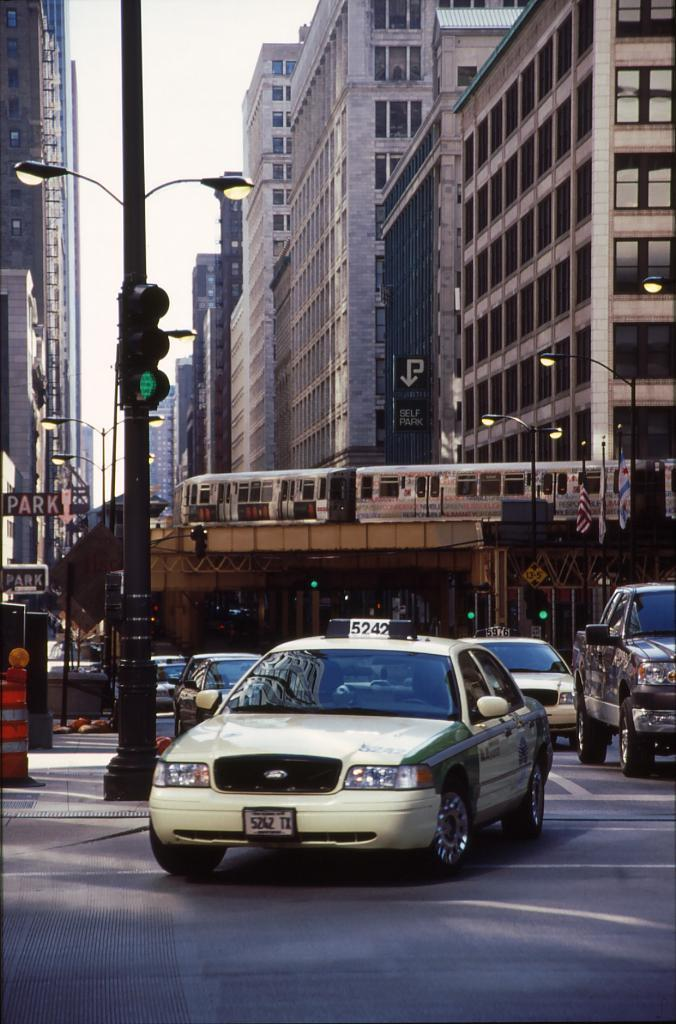Provide a one-sentence caption for the provided image. A taxi cab beneath a monorail with the number 5242 on the top. 